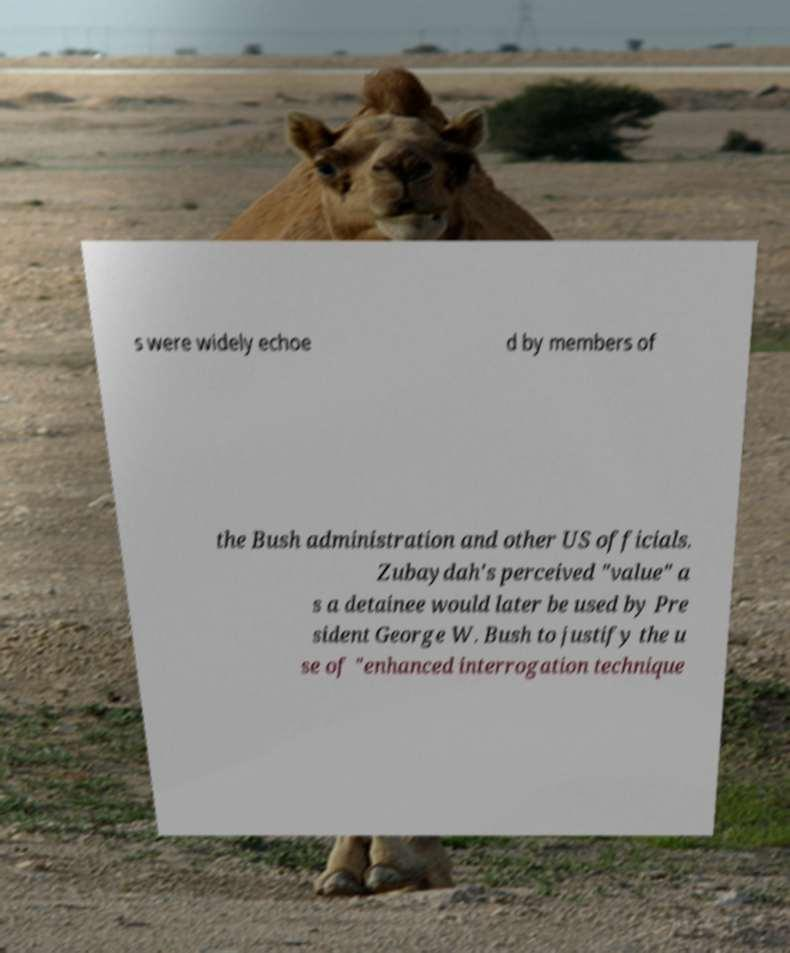Could you assist in decoding the text presented in this image and type it out clearly? s were widely echoe d by members of the Bush administration and other US officials. Zubaydah's perceived "value" a s a detainee would later be used by Pre sident George W. Bush to justify the u se of "enhanced interrogation technique 